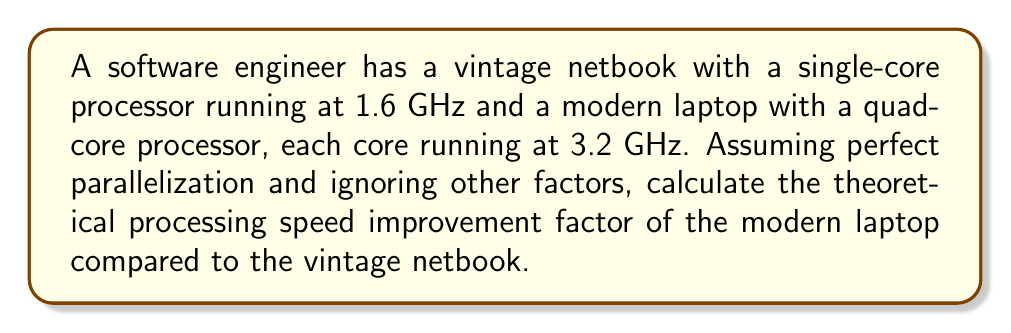Can you answer this question? Let's approach this step-by-step:

1. Calculate the processing power of the vintage netbook:
   $$P_{netbook} = 1 \text{ core} \times 1.6 \text{ GHz} = 1.6 \text{ GHz}$$

2. Calculate the processing power of the modern laptop:
   $$P_{laptop} = 4 \text{ cores} \times 3.2 \text{ GHz} = 12.8 \text{ GHz}$$

3. Calculate the improvement factor by dividing the modern laptop's processing power by the vintage netbook's:
   $$\text{Improvement Factor} = \frac{P_{laptop}}{P_{netbook}} = \frac{12.8 \text{ GHz}}{1.6 \text{ GHz}} = 8$$

Therefore, assuming perfect parallelization and ignoring other factors, the modern laptop is theoretically 8 times faster than the vintage netbook.
Answer: 8 